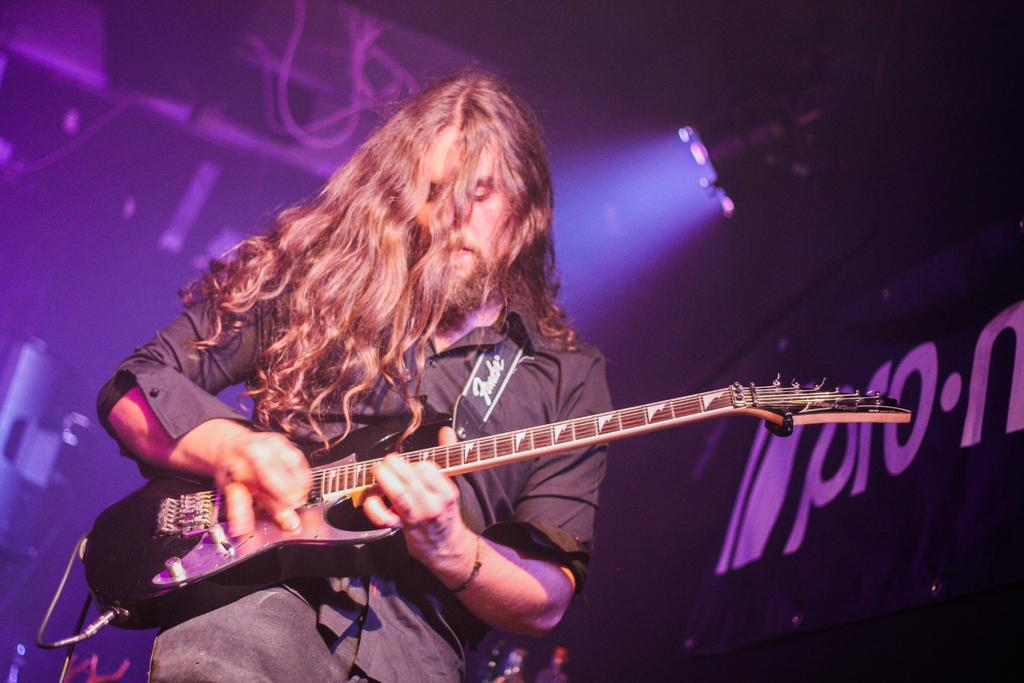What is the man in the image doing? The man is playing the guitar in the image. What object is the man holding while playing the guitar? The man is holding a guitar in the image. Can you describe the man's appearance? The man has long hair in the image. What can be seen in the background of the image? There is a letter board in the background of the image. What type of setting is depicted in the image? The image appears to be a stage performance. What type of apparel is the man wearing while rubbing the argument on the letter board? There is no mention of the man rubbing an argument on the letter board in the image. Additionally, the provided facts do not mention the man's apparel. 